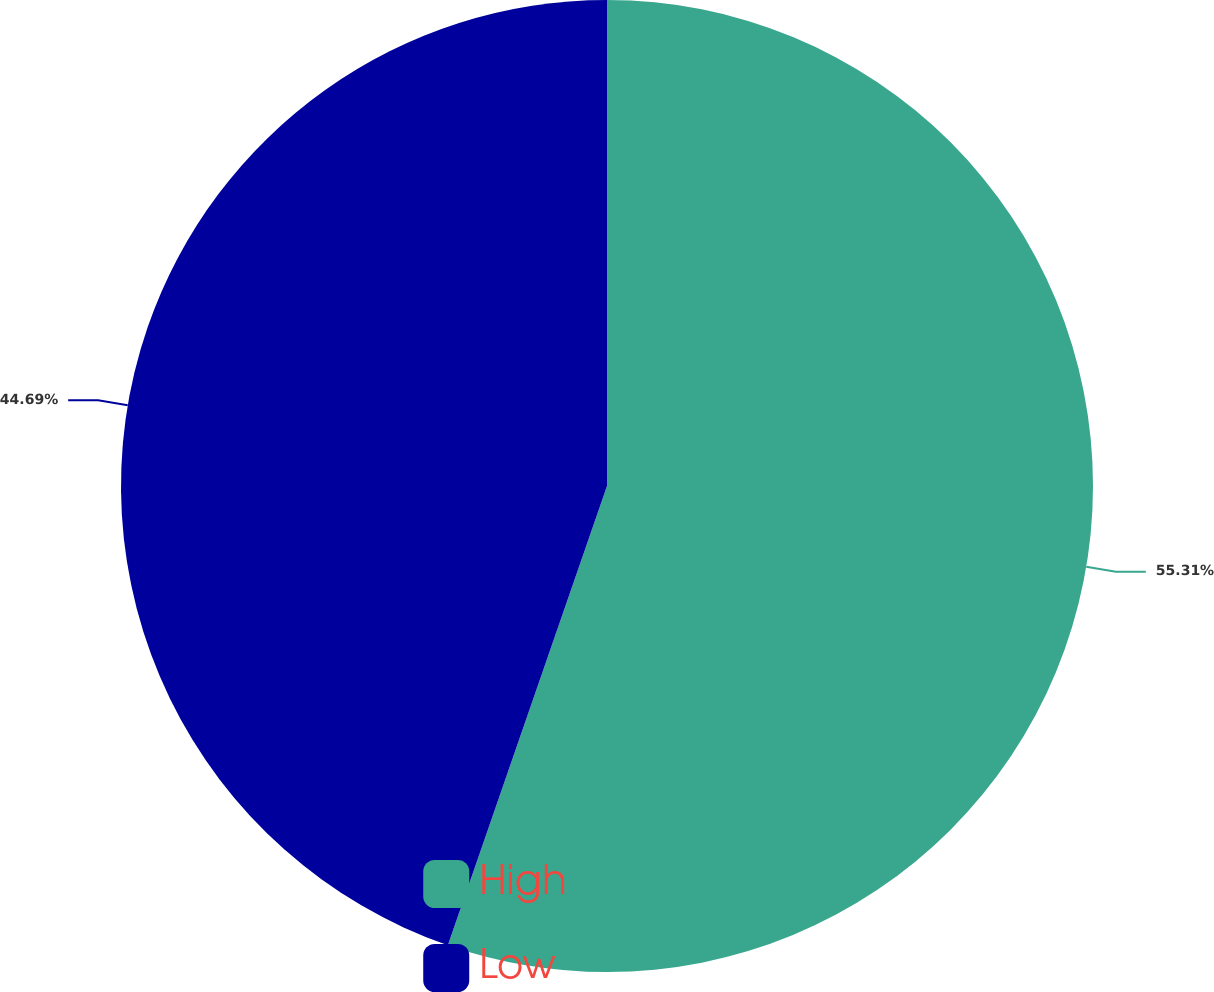<chart> <loc_0><loc_0><loc_500><loc_500><pie_chart><fcel>High<fcel>Low<nl><fcel>55.31%<fcel>44.69%<nl></chart> 